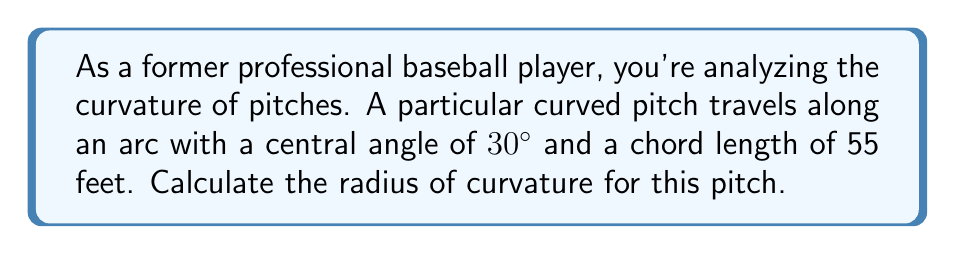Can you solve this math problem? To solve this problem, we'll use the relationship between the chord length, central angle, and radius in a circular arc. Let's break it down step-by-step:

1) First, recall the formula for the chord length ($c$) in terms of the radius ($r$) and the central angle ($\theta$) in radians:

   $$c = 2r \sin(\frac{\theta}{2})$$

2) We're given the chord length ($c = 55$ feet) and the central angle ($\theta = 30^\circ$). However, we need to convert the angle to radians:

   $$30^\circ = \frac{30 \pi}{180} = \frac{\pi}{6} \text{ radians}$$

3) Now, let's substitute these values into our equation:

   $$55 = 2r \sin(\frac{\pi}{12})$$

4) To solve for $r$, we'll divide both sides by $2\sin(\frac{\pi}{12})$:

   $$r = \frac{55}{2\sin(\frac{\pi}{12})}$$

5) Now we can calculate this value:

   $$r = \frac{55}{2 \sin(\frac{\pi}{12})} \approx 105.8355$$

6) Rounding to two decimal places, we get our final answer.

[asy]
import geometry;

pair O = (0,0);
real r = 105.84;
real theta = pi/6;
draw(Circle(O, r), rgb(0,0,1));
pair A = r*dir(90+theta/2);
pair B = r*dir(90-theta/2);
draw(A--B, rgb(1,0,0));
draw(O--A);
draw(O--B);
label("r", (O--A)/2, E);
label("55 ft", (A--B)/2, N);
label("30°", O, SW);
[/asy]
Answer: The radius of curvature for the pitch is approximately 105.84 feet. 